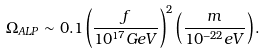<formula> <loc_0><loc_0><loc_500><loc_500>\Omega _ { A L P } \sim 0 . 1 \left ( \frac { f } { 1 0 ^ { 1 7 } G e V } \right ) ^ { 2 } \left ( \frac { m } { 1 0 ^ { - 2 2 } e V } \right ) .</formula> 